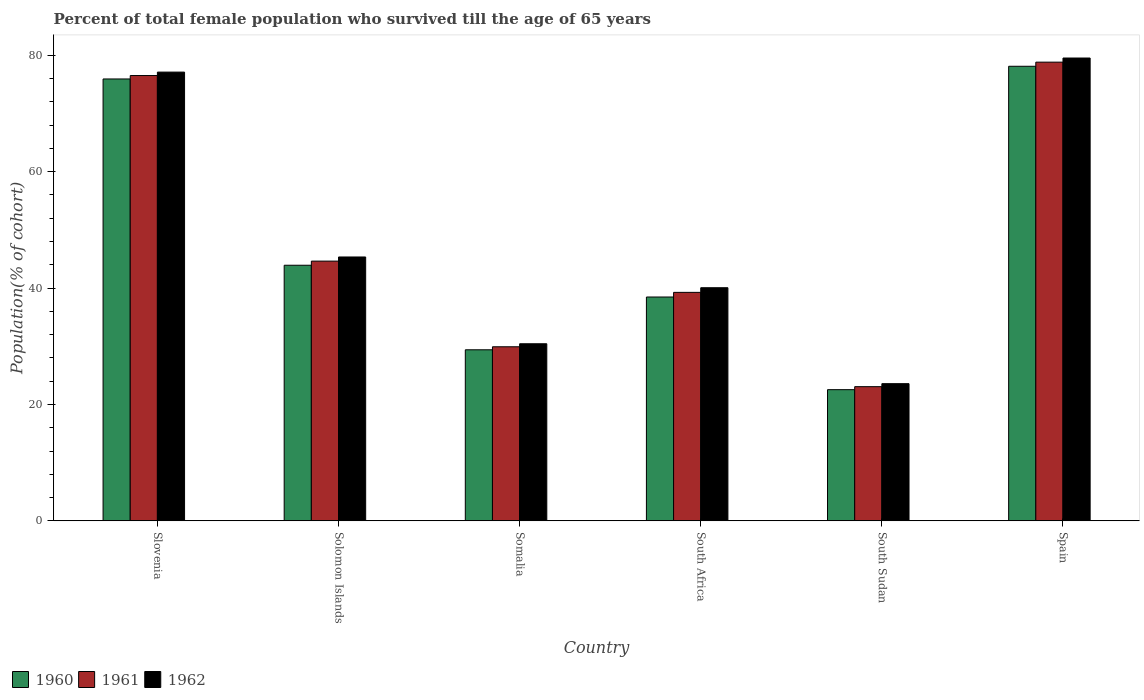How many different coloured bars are there?
Provide a succinct answer. 3. Are the number of bars per tick equal to the number of legend labels?
Your response must be concise. Yes. How many bars are there on the 5th tick from the left?
Ensure brevity in your answer.  3. What is the label of the 5th group of bars from the left?
Your response must be concise. South Sudan. What is the percentage of total female population who survived till the age of 65 years in 1961 in Somalia?
Make the answer very short. 29.91. Across all countries, what is the maximum percentage of total female population who survived till the age of 65 years in 1962?
Your response must be concise. 79.53. Across all countries, what is the minimum percentage of total female population who survived till the age of 65 years in 1962?
Give a very brief answer. 23.57. In which country was the percentage of total female population who survived till the age of 65 years in 1961 maximum?
Your answer should be very brief. Spain. In which country was the percentage of total female population who survived till the age of 65 years in 1962 minimum?
Your answer should be compact. South Sudan. What is the total percentage of total female population who survived till the age of 65 years in 1962 in the graph?
Provide a succinct answer. 296.05. What is the difference between the percentage of total female population who survived till the age of 65 years in 1961 in Solomon Islands and that in Spain?
Make the answer very short. -34.19. What is the difference between the percentage of total female population who survived till the age of 65 years in 1962 in Solomon Islands and the percentage of total female population who survived till the age of 65 years in 1961 in Spain?
Keep it short and to the point. -33.48. What is the average percentage of total female population who survived till the age of 65 years in 1962 per country?
Offer a very short reply. 49.34. What is the difference between the percentage of total female population who survived till the age of 65 years of/in 1960 and percentage of total female population who survived till the age of 65 years of/in 1961 in Somalia?
Keep it short and to the point. -0.52. In how many countries, is the percentage of total female population who survived till the age of 65 years in 1962 greater than 28 %?
Your response must be concise. 5. What is the ratio of the percentage of total female population who survived till the age of 65 years in 1960 in South Sudan to that in Spain?
Offer a very short reply. 0.29. What is the difference between the highest and the second highest percentage of total female population who survived till the age of 65 years in 1962?
Provide a short and direct response. -31.77. What is the difference between the highest and the lowest percentage of total female population who survived till the age of 65 years in 1960?
Provide a succinct answer. 55.58. In how many countries, is the percentage of total female population who survived till the age of 65 years in 1960 greater than the average percentage of total female population who survived till the age of 65 years in 1960 taken over all countries?
Provide a succinct answer. 2. What does the 1st bar from the left in Somalia represents?
Make the answer very short. 1960. What does the 3rd bar from the right in Somalia represents?
Offer a terse response. 1960. How many countries are there in the graph?
Make the answer very short. 6. Are the values on the major ticks of Y-axis written in scientific E-notation?
Your response must be concise. No. Does the graph contain any zero values?
Offer a very short reply. No. Where does the legend appear in the graph?
Ensure brevity in your answer.  Bottom left. How many legend labels are there?
Make the answer very short. 3. How are the legend labels stacked?
Your answer should be very brief. Horizontal. What is the title of the graph?
Provide a short and direct response. Percent of total female population who survived till the age of 65 years. What is the label or title of the X-axis?
Keep it short and to the point. Country. What is the label or title of the Y-axis?
Make the answer very short. Population(% of cohort). What is the Population(% of cohort) in 1960 in Slovenia?
Offer a terse response. 75.93. What is the Population(% of cohort) of 1961 in Slovenia?
Your answer should be very brief. 76.52. What is the Population(% of cohort) in 1962 in Slovenia?
Ensure brevity in your answer.  77.11. What is the Population(% of cohort) in 1960 in Solomon Islands?
Make the answer very short. 43.92. What is the Population(% of cohort) in 1961 in Solomon Islands?
Provide a short and direct response. 44.63. What is the Population(% of cohort) in 1962 in Solomon Islands?
Your response must be concise. 45.34. What is the Population(% of cohort) in 1960 in Somalia?
Make the answer very short. 29.39. What is the Population(% of cohort) in 1961 in Somalia?
Provide a succinct answer. 29.91. What is the Population(% of cohort) in 1962 in Somalia?
Your answer should be compact. 30.43. What is the Population(% of cohort) in 1960 in South Africa?
Offer a very short reply. 38.46. What is the Population(% of cohort) of 1961 in South Africa?
Provide a short and direct response. 39.26. What is the Population(% of cohort) in 1962 in South Africa?
Make the answer very short. 40.06. What is the Population(% of cohort) in 1960 in South Sudan?
Make the answer very short. 22.54. What is the Population(% of cohort) in 1961 in South Sudan?
Ensure brevity in your answer.  23.06. What is the Population(% of cohort) of 1962 in South Sudan?
Provide a short and direct response. 23.57. What is the Population(% of cohort) in 1960 in Spain?
Keep it short and to the point. 78.12. What is the Population(% of cohort) of 1961 in Spain?
Your answer should be compact. 78.83. What is the Population(% of cohort) of 1962 in Spain?
Your answer should be compact. 79.53. Across all countries, what is the maximum Population(% of cohort) of 1960?
Your response must be concise. 78.12. Across all countries, what is the maximum Population(% of cohort) of 1961?
Make the answer very short. 78.83. Across all countries, what is the maximum Population(% of cohort) in 1962?
Your response must be concise. 79.53. Across all countries, what is the minimum Population(% of cohort) in 1960?
Give a very brief answer. 22.54. Across all countries, what is the minimum Population(% of cohort) in 1961?
Provide a succinct answer. 23.06. Across all countries, what is the minimum Population(% of cohort) in 1962?
Keep it short and to the point. 23.57. What is the total Population(% of cohort) in 1960 in the graph?
Your answer should be very brief. 288.37. What is the total Population(% of cohort) in 1961 in the graph?
Provide a short and direct response. 292.21. What is the total Population(% of cohort) of 1962 in the graph?
Keep it short and to the point. 296.05. What is the difference between the Population(% of cohort) of 1960 in Slovenia and that in Solomon Islands?
Provide a short and direct response. 32.01. What is the difference between the Population(% of cohort) of 1961 in Slovenia and that in Solomon Islands?
Your answer should be compact. 31.89. What is the difference between the Population(% of cohort) of 1962 in Slovenia and that in Solomon Islands?
Provide a short and direct response. 31.77. What is the difference between the Population(% of cohort) in 1960 in Slovenia and that in Somalia?
Your answer should be compact. 46.54. What is the difference between the Population(% of cohort) in 1961 in Slovenia and that in Somalia?
Keep it short and to the point. 46.61. What is the difference between the Population(% of cohort) of 1962 in Slovenia and that in Somalia?
Your answer should be compact. 46.68. What is the difference between the Population(% of cohort) in 1960 in Slovenia and that in South Africa?
Provide a succinct answer. 37.47. What is the difference between the Population(% of cohort) of 1961 in Slovenia and that in South Africa?
Provide a succinct answer. 37.26. What is the difference between the Population(% of cohort) in 1962 in Slovenia and that in South Africa?
Offer a very short reply. 37.05. What is the difference between the Population(% of cohort) of 1960 in Slovenia and that in South Sudan?
Provide a succinct answer. 53.39. What is the difference between the Population(% of cohort) of 1961 in Slovenia and that in South Sudan?
Your response must be concise. 53.47. What is the difference between the Population(% of cohort) in 1962 in Slovenia and that in South Sudan?
Your answer should be very brief. 53.54. What is the difference between the Population(% of cohort) in 1960 in Slovenia and that in Spain?
Provide a short and direct response. -2.18. What is the difference between the Population(% of cohort) of 1961 in Slovenia and that in Spain?
Offer a very short reply. -2.3. What is the difference between the Population(% of cohort) in 1962 in Slovenia and that in Spain?
Ensure brevity in your answer.  -2.42. What is the difference between the Population(% of cohort) of 1960 in Solomon Islands and that in Somalia?
Keep it short and to the point. 14.53. What is the difference between the Population(% of cohort) of 1961 in Solomon Islands and that in Somalia?
Keep it short and to the point. 14.72. What is the difference between the Population(% of cohort) in 1962 in Solomon Islands and that in Somalia?
Keep it short and to the point. 14.91. What is the difference between the Population(% of cohort) in 1960 in Solomon Islands and that in South Africa?
Provide a succinct answer. 5.46. What is the difference between the Population(% of cohort) in 1961 in Solomon Islands and that in South Africa?
Provide a succinct answer. 5.37. What is the difference between the Population(% of cohort) of 1962 in Solomon Islands and that in South Africa?
Offer a terse response. 5.28. What is the difference between the Population(% of cohort) of 1960 in Solomon Islands and that in South Sudan?
Ensure brevity in your answer.  21.38. What is the difference between the Population(% of cohort) of 1961 in Solomon Islands and that in South Sudan?
Provide a succinct answer. 21.58. What is the difference between the Population(% of cohort) of 1962 in Solomon Islands and that in South Sudan?
Your response must be concise. 21.77. What is the difference between the Population(% of cohort) of 1960 in Solomon Islands and that in Spain?
Your response must be concise. -34.19. What is the difference between the Population(% of cohort) of 1961 in Solomon Islands and that in Spain?
Provide a succinct answer. -34.19. What is the difference between the Population(% of cohort) in 1962 in Solomon Islands and that in Spain?
Give a very brief answer. -34.19. What is the difference between the Population(% of cohort) of 1960 in Somalia and that in South Africa?
Offer a terse response. -9.07. What is the difference between the Population(% of cohort) of 1961 in Somalia and that in South Africa?
Give a very brief answer. -9.35. What is the difference between the Population(% of cohort) of 1962 in Somalia and that in South Africa?
Offer a very short reply. -9.63. What is the difference between the Population(% of cohort) of 1960 in Somalia and that in South Sudan?
Provide a short and direct response. 6.85. What is the difference between the Population(% of cohort) of 1961 in Somalia and that in South Sudan?
Provide a succinct answer. 6.85. What is the difference between the Population(% of cohort) in 1962 in Somalia and that in South Sudan?
Your response must be concise. 6.86. What is the difference between the Population(% of cohort) in 1960 in Somalia and that in Spain?
Your answer should be compact. -48.72. What is the difference between the Population(% of cohort) in 1961 in Somalia and that in Spain?
Offer a very short reply. -48.91. What is the difference between the Population(% of cohort) of 1962 in Somalia and that in Spain?
Your answer should be very brief. -49.11. What is the difference between the Population(% of cohort) of 1960 in South Africa and that in South Sudan?
Your answer should be very brief. 15.92. What is the difference between the Population(% of cohort) in 1961 in South Africa and that in South Sudan?
Provide a short and direct response. 16.2. What is the difference between the Population(% of cohort) in 1962 in South Africa and that in South Sudan?
Make the answer very short. 16.49. What is the difference between the Population(% of cohort) in 1960 in South Africa and that in Spain?
Offer a very short reply. -39.65. What is the difference between the Population(% of cohort) in 1961 in South Africa and that in Spain?
Your response must be concise. -39.56. What is the difference between the Population(% of cohort) of 1962 in South Africa and that in Spain?
Ensure brevity in your answer.  -39.47. What is the difference between the Population(% of cohort) in 1960 in South Sudan and that in Spain?
Offer a terse response. -55.58. What is the difference between the Population(% of cohort) in 1961 in South Sudan and that in Spain?
Offer a terse response. -55.77. What is the difference between the Population(% of cohort) of 1962 in South Sudan and that in Spain?
Offer a very short reply. -55.96. What is the difference between the Population(% of cohort) of 1960 in Slovenia and the Population(% of cohort) of 1961 in Solomon Islands?
Your response must be concise. 31.3. What is the difference between the Population(% of cohort) in 1960 in Slovenia and the Population(% of cohort) in 1962 in Solomon Islands?
Your response must be concise. 30.59. What is the difference between the Population(% of cohort) in 1961 in Slovenia and the Population(% of cohort) in 1962 in Solomon Islands?
Offer a very short reply. 31.18. What is the difference between the Population(% of cohort) of 1960 in Slovenia and the Population(% of cohort) of 1961 in Somalia?
Make the answer very short. 46.02. What is the difference between the Population(% of cohort) of 1960 in Slovenia and the Population(% of cohort) of 1962 in Somalia?
Offer a very short reply. 45.5. What is the difference between the Population(% of cohort) of 1961 in Slovenia and the Population(% of cohort) of 1962 in Somalia?
Keep it short and to the point. 46.09. What is the difference between the Population(% of cohort) in 1960 in Slovenia and the Population(% of cohort) in 1961 in South Africa?
Your response must be concise. 36.67. What is the difference between the Population(% of cohort) of 1960 in Slovenia and the Population(% of cohort) of 1962 in South Africa?
Your answer should be compact. 35.87. What is the difference between the Population(% of cohort) in 1961 in Slovenia and the Population(% of cohort) in 1962 in South Africa?
Provide a succinct answer. 36.46. What is the difference between the Population(% of cohort) of 1960 in Slovenia and the Population(% of cohort) of 1961 in South Sudan?
Offer a terse response. 52.88. What is the difference between the Population(% of cohort) in 1960 in Slovenia and the Population(% of cohort) in 1962 in South Sudan?
Ensure brevity in your answer.  52.36. What is the difference between the Population(% of cohort) in 1961 in Slovenia and the Population(% of cohort) in 1962 in South Sudan?
Offer a very short reply. 52.95. What is the difference between the Population(% of cohort) in 1960 in Slovenia and the Population(% of cohort) in 1961 in Spain?
Offer a very short reply. -2.89. What is the difference between the Population(% of cohort) in 1960 in Slovenia and the Population(% of cohort) in 1962 in Spain?
Your answer should be compact. -3.6. What is the difference between the Population(% of cohort) of 1961 in Slovenia and the Population(% of cohort) of 1962 in Spain?
Make the answer very short. -3.01. What is the difference between the Population(% of cohort) in 1960 in Solomon Islands and the Population(% of cohort) in 1961 in Somalia?
Your response must be concise. 14.01. What is the difference between the Population(% of cohort) of 1960 in Solomon Islands and the Population(% of cohort) of 1962 in Somalia?
Provide a succinct answer. 13.49. What is the difference between the Population(% of cohort) of 1961 in Solomon Islands and the Population(% of cohort) of 1962 in Somalia?
Offer a terse response. 14.2. What is the difference between the Population(% of cohort) of 1960 in Solomon Islands and the Population(% of cohort) of 1961 in South Africa?
Provide a short and direct response. 4.66. What is the difference between the Population(% of cohort) of 1960 in Solomon Islands and the Population(% of cohort) of 1962 in South Africa?
Your answer should be compact. 3.86. What is the difference between the Population(% of cohort) in 1961 in Solomon Islands and the Population(% of cohort) in 1962 in South Africa?
Your response must be concise. 4.57. What is the difference between the Population(% of cohort) of 1960 in Solomon Islands and the Population(% of cohort) of 1961 in South Sudan?
Your answer should be compact. 20.87. What is the difference between the Population(% of cohort) of 1960 in Solomon Islands and the Population(% of cohort) of 1962 in South Sudan?
Ensure brevity in your answer.  20.35. What is the difference between the Population(% of cohort) of 1961 in Solomon Islands and the Population(% of cohort) of 1962 in South Sudan?
Make the answer very short. 21.06. What is the difference between the Population(% of cohort) in 1960 in Solomon Islands and the Population(% of cohort) in 1961 in Spain?
Provide a succinct answer. -34.9. What is the difference between the Population(% of cohort) in 1960 in Solomon Islands and the Population(% of cohort) in 1962 in Spain?
Keep it short and to the point. -35.61. What is the difference between the Population(% of cohort) of 1961 in Solomon Islands and the Population(% of cohort) of 1962 in Spain?
Provide a succinct answer. -34.9. What is the difference between the Population(% of cohort) in 1960 in Somalia and the Population(% of cohort) in 1961 in South Africa?
Provide a succinct answer. -9.87. What is the difference between the Population(% of cohort) of 1960 in Somalia and the Population(% of cohort) of 1962 in South Africa?
Your answer should be compact. -10.67. What is the difference between the Population(% of cohort) of 1961 in Somalia and the Population(% of cohort) of 1962 in South Africa?
Give a very brief answer. -10.15. What is the difference between the Population(% of cohort) in 1960 in Somalia and the Population(% of cohort) in 1961 in South Sudan?
Make the answer very short. 6.34. What is the difference between the Population(% of cohort) of 1960 in Somalia and the Population(% of cohort) of 1962 in South Sudan?
Offer a very short reply. 5.82. What is the difference between the Population(% of cohort) of 1961 in Somalia and the Population(% of cohort) of 1962 in South Sudan?
Provide a succinct answer. 6.34. What is the difference between the Population(% of cohort) of 1960 in Somalia and the Population(% of cohort) of 1961 in Spain?
Make the answer very short. -49.43. What is the difference between the Population(% of cohort) in 1960 in Somalia and the Population(% of cohort) in 1962 in Spain?
Ensure brevity in your answer.  -50.14. What is the difference between the Population(% of cohort) in 1961 in Somalia and the Population(% of cohort) in 1962 in Spain?
Give a very brief answer. -49.62. What is the difference between the Population(% of cohort) in 1960 in South Africa and the Population(% of cohort) in 1961 in South Sudan?
Make the answer very short. 15.41. What is the difference between the Population(% of cohort) in 1960 in South Africa and the Population(% of cohort) in 1962 in South Sudan?
Provide a succinct answer. 14.89. What is the difference between the Population(% of cohort) in 1961 in South Africa and the Population(% of cohort) in 1962 in South Sudan?
Provide a short and direct response. 15.69. What is the difference between the Population(% of cohort) in 1960 in South Africa and the Population(% of cohort) in 1961 in Spain?
Your answer should be compact. -40.36. What is the difference between the Population(% of cohort) in 1960 in South Africa and the Population(% of cohort) in 1962 in Spain?
Make the answer very short. -41.07. What is the difference between the Population(% of cohort) in 1961 in South Africa and the Population(% of cohort) in 1962 in Spain?
Your answer should be very brief. -40.27. What is the difference between the Population(% of cohort) in 1960 in South Sudan and the Population(% of cohort) in 1961 in Spain?
Your answer should be very brief. -56.29. What is the difference between the Population(% of cohort) of 1960 in South Sudan and the Population(% of cohort) of 1962 in Spain?
Your answer should be very brief. -56.99. What is the difference between the Population(% of cohort) in 1961 in South Sudan and the Population(% of cohort) in 1962 in Spain?
Give a very brief answer. -56.48. What is the average Population(% of cohort) of 1960 per country?
Give a very brief answer. 48.06. What is the average Population(% of cohort) of 1961 per country?
Make the answer very short. 48.7. What is the average Population(% of cohort) of 1962 per country?
Your answer should be compact. 49.34. What is the difference between the Population(% of cohort) of 1960 and Population(% of cohort) of 1961 in Slovenia?
Your answer should be compact. -0.59. What is the difference between the Population(% of cohort) in 1960 and Population(% of cohort) in 1962 in Slovenia?
Offer a terse response. -1.18. What is the difference between the Population(% of cohort) of 1961 and Population(% of cohort) of 1962 in Slovenia?
Keep it short and to the point. -0.59. What is the difference between the Population(% of cohort) in 1960 and Population(% of cohort) in 1961 in Solomon Islands?
Offer a very short reply. -0.71. What is the difference between the Population(% of cohort) of 1960 and Population(% of cohort) of 1962 in Solomon Islands?
Provide a succinct answer. -1.42. What is the difference between the Population(% of cohort) in 1961 and Population(% of cohort) in 1962 in Solomon Islands?
Provide a short and direct response. -0.71. What is the difference between the Population(% of cohort) of 1960 and Population(% of cohort) of 1961 in Somalia?
Your answer should be compact. -0.52. What is the difference between the Population(% of cohort) of 1960 and Population(% of cohort) of 1962 in Somalia?
Make the answer very short. -1.04. What is the difference between the Population(% of cohort) of 1961 and Population(% of cohort) of 1962 in Somalia?
Your answer should be compact. -0.52. What is the difference between the Population(% of cohort) in 1960 and Population(% of cohort) in 1961 in South Africa?
Make the answer very short. -0.8. What is the difference between the Population(% of cohort) of 1960 and Population(% of cohort) of 1962 in South Africa?
Offer a very short reply. -1.6. What is the difference between the Population(% of cohort) of 1961 and Population(% of cohort) of 1962 in South Africa?
Provide a short and direct response. -0.8. What is the difference between the Population(% of cohort) in 1960 and Population(% of cohort) in 1961 in South Sudan?
Offer a terse response. -0.52. What is the difference between the Population(% of cohort) of 1960 and Population(% of cohort) of 1962 in South Sudan?
Offer a very short reply. -1.03. What is the difference between the Population(% of cohort) in 1961 and Population(% of cohort) in 1962 in South Sudan?
Keep it short and to the point. -0.52. What is the difference between the Population(% of cohort) in 1960 and Population(% of cohort) in 1961 in Spain?
Give a very brief answer. -0.71. What is the difference between the Population(% of cohort) in 1960 and Population(% of cohort) in 1962 in Spain?
Your answer should be compact. -1.42. What is the difference between the Population(% of cohort) in 1961 and Population(% of cohort) in 1962 in Spain?
Give a very brief answer. -0.71. What is the ratio of the Population(% of cohort) of 1960 in Slovenia to that in Solomon Islands?
Offer a very short reply. 1.73. What is the ratio of the Population(% of cohort) of 1961 in Slovenia to that in Solomon Islands?
Ensure brevity in your answer.  1.71. What is the ratio of the Population(% of cohort) of 1962 in Slovenia to that in Solomon Islands?
Provide a short and direct response. 1.7. What is the ratio of the Population(% of cohort) of 1960 in Slovenia to that in Somalia?
Offer a very short reply. 2.58. What is the ratio of the Population(% of cohort) of 1961 in Slovenia to that in Somalia?
Provide a short and direct response. 2.56. What is the ratio of the Population(% of cohort) in 1962 in Slovenia to that in Somalia?
Ensure brevity in your answer.  2.53. What is the ratio of the Population(% of cohort) of 1960 in Slovenia to that in South Africa?
Ensure brevity in your answer.  1.97. What is the ratio of the Population(% of cohort) of 1961 in Slovenia to that in South Africa?
Make the answer very short. 1.95. What is the ratio of the Population(% of cohort) in 1962 in Slovenia to that in South Africa?
Provide a succinct answer. 1.93. What is the ratio of the Population(% of cohort) in 1960 in Slovenia to that in South Sudan?
Give a very brief answer. 3.37. What is the ratio of the Population(% of cohort) of 1961 in Slovenia to that in South Sudan?
Offer a terse response. 3.32. What is the ratio of the Population(% of cohort) in 1962 in Slovenia to that in South Sudan?
Offer a terse response. 3.27. What is the ratio of the Population(% of cohort) of 1960 in Slovenia to that in Spain?
Your answer should be very brief. 0.97. What is the ratio of the Population(% of cohort) in 1961 in Slovenia to that in Spain?
Keep it short and to the point. 0.97. What is the ratio of the Population(% of cohort) of 1962 in Slovenia to that in Spain?
Provide a succinct answer. 0.97. What is the ratio of the Population(% of cohort) of 1960 in Solomon Islands to that in Somalia?
Your answer should be very brief. 1.49. What is the ratio of the Population(% of cohort) in 1961 in Solomon Islands to that in Somalia?
Make the answer very short. 1.49. What is the ratio of the Population(% of cohort) in 1962 in Solomon Islands to that in Somalia?
Offer a terse response. 1.49. What is the ratio of the Population(% of cohort) in 1960 in Solomon Islands to that in South Africa?
Provide a short and direct response. 1.14. What is the ratio of the Population(% of cohort) in 1961 in Solomon Islands to that in South Africa?
Offer a terse response. 1.14. What is the ratio of the Population(% of cohort) in 1962 in Solomon Islands to that in South Africa?
Offer a very short reply. 1.13. What is the ratio of the Population(% of cohort) of 1960 in Solomon Islands to that in South Sudan?
Your answer should be compact. 1.95. What is the ratio of the Population(% of cohort) of 1961 in Solomon Islands to that in South Sudan?
Offer a terse response. 1.94. What is the ratio of the Population(% of cohort) of 1962 in Solomon Islands to that in South Sudan?
Provide a succinct answer. 1.92. What is the ratio of the Population(% of cohort) in 1960 in Solomon Islands to that in Spain?
Your response must be concise. 0.56. What is the ratio of the Population(% of cohort) of 1961 in Solomon Islands to that in Spain?
Offer a very short reply. 0.57. What is the ratio of the Population(% of cohort) of 1962 in Solomon Islands to that in Spain?
Ensure brevity in your answer.  0.57. What is the ratio of the Population(% of cohort) of 1960 in Somalia to that in South Africa?
Your answer should be very brief. 0.76. What is the ratio of the Population(% of cohort) of 1961 in Somalia to that in South Africa?
Give a very brief answer. 0.76. What is the ratio of the Population(% of cohort) of 1962 in Somalia to that in South Africa?
Ensure brevity in your answer.  0.76. What is the ratio of the Population(% of cohort) in 1960 in Somalia to that in South Sudan?
Provide a succinct answer. 1.3. What is the ratio of the Population(% of cohort) of 1961 in Somalia to that in South Sudan?
Give a very brief answer. 1.3. What is the ratio of the Population(% of cohort) of 1962 in Somalia to that in South Sudan?
Give a very brief answer. 1.29. What is the ratio of the Population(% of cohort) of 1960 in Somalia to that in Spain?
Make the answer very short. 0.38. What is the ratio of the Population(% of cohort) of 1961 in Somalia to that in Spain?
Offer a very short reply. 0.38. What is the ratio of the Population(% of cohort) in 1962 in Somalia to that in Spain?
Ensure brevity in your answer.  0.38. What is the ratio of the Population(% of cohort) of 1960 in South Africa to that in South Sudan?
Your response must be concise. 1.71. What is the ratio of the Population(% of cohort) in 1961 in South Africa to that in South Sudan?
Provide a succinct answer. 1.7. What is the ratio of the Population(% of cohort) in 1962 in South Africa to that in South Sudan?
Offer a very short reply. 1.7. What is the ratio of the Population(% of cohort) in 1960 in South Africa to that in Spain?
Keep it short and to the point. 0.49. What is the ratio of the Population(% of cohort) in 1961 in South Africa to that in Spain?
Your response must be concise. 0.5. What is the ratio of the Population(% of cohort) of 1962 in South Africa to that in Spain?
Your answer should be compact. 0.5. What is the ratio of the Population(% of cohort) in 1960 in South Sudan to that in Spain?
Your answer should be very brief. 0.29. What is the ratio of the Population(% of cohort) in 1961 in South Sudan to that in Spain?
Keep it short and to the point. 0.29. What is the ratio of the Population(% of cohort) in 1962 in South Sudan to that in Spain?
Keep it short and to the point. 0.3. What is the difference between the highest and the second highest Population(% of cohort) of 1960?
Make the answer very short. 2.18. What is the difference between the highest and the second highest Population(% of cohort) of 1961?
Make the answer very short. 2.3. What is the difference between the highest and the second highest Population(% of cohort) in 1962?
Keep it short and to the point. 2.42. What is the difference between the highest and the lowest Population(% of cohort) in 1960?
Provide a succinct answer. 55.58. What is the difference between the highest and the lowest Population(% of cohort) of 1961?
Your answer should be compact. 55.77. What is the difference between the highest and the lowest Population(% of cohort) in 1962?
Give a very brief answer. 55.96. 